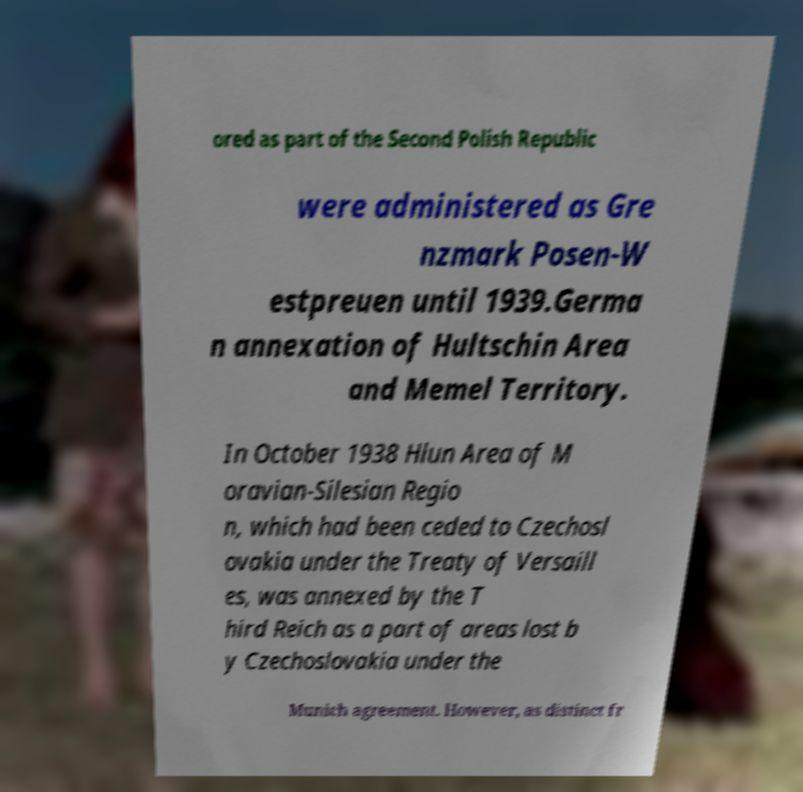Please identify and transcribe the text found in this image. ored as part of the Second Polish Republic were administered as Gre nzmark Posen-W estpreuen until 1939.Germa n annexation of Hultschin Area and Memel Territory. In October 1938 Hlun Area of M oravian-Silesian Regio n, which had been ceded to Czechosl ovakia under the Treaty of Versaill es, was annexed by the T hird Reich as a part of areas lost b y Czechoslovakia under the Munich agreement. However, as distinct fr 